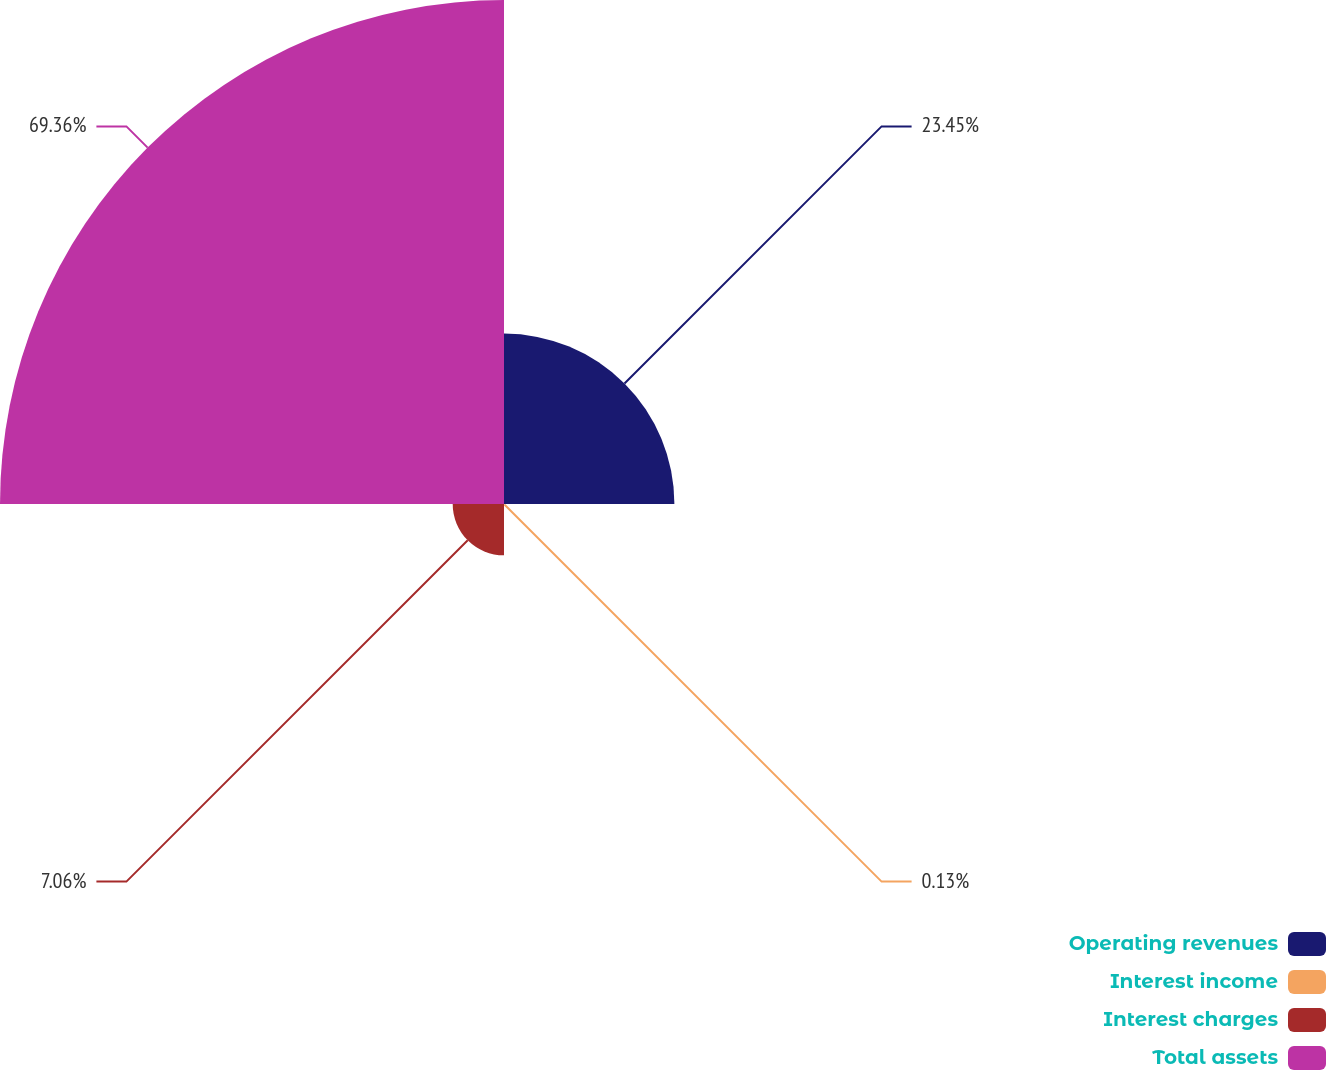Convert chart to OTSL. <chart><loc_0><loc_0><loc_500><loc_500><pie_chart><fcel>Operating revenues<fcel>Interest income<fcel>Interest charges<fcel>Total assets<nl><fcel>23.45%<fcel>0.13%<fcel>7.06%<fcel>69.36%<nl></chart> 